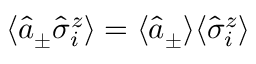<formula> <loc_0><loc_0><loc_500><loc_500>\langle \hat { a } _ { \pm } \hat { \sigma } _ { i } ^ { z } \rangle = \langle \hat { a } _ { \pm } \rangle \langle \hat { \sigma } _ { i } ^ { z } \rangle</formula> 